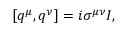<formula> <loc_0><loc_0><loc_500><loc_500>[ q ^ { \mu } , q ^ { \nu } ] = i \sigma ^ { \mu \nu } I ,</formula> 